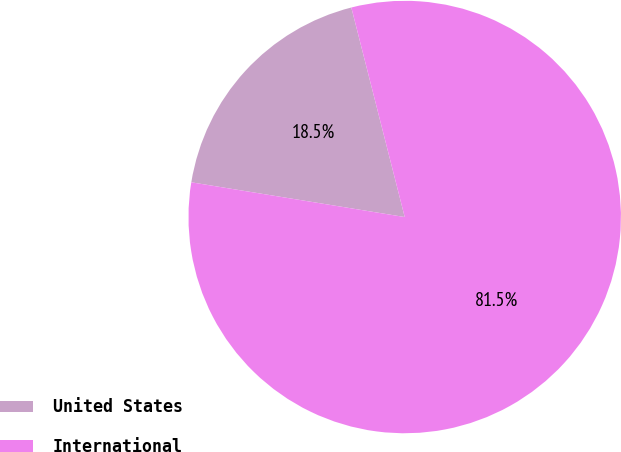Convert chart to OTSL. <chart><loc_0><loc_0><loc_500><loc_500><pie_chart><fcel>United States<fcel>International<nl><fcel>18.46%<fcel>81.54%<nl></chart> 